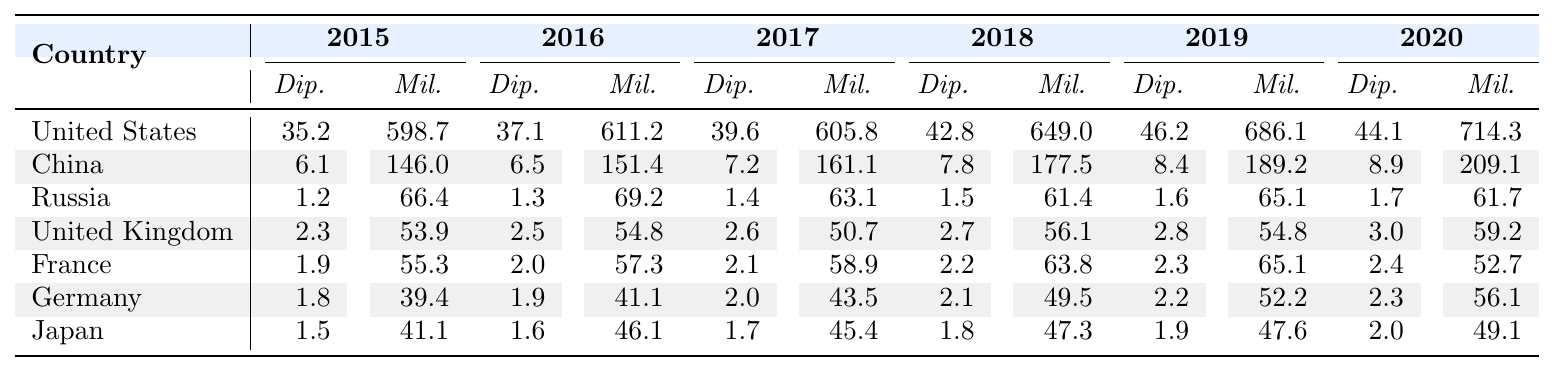What was the military spending of the United States in 2019? According to the table, the military spending for the United States in 2019 is listed as 686.1
Answer: 686.1 Which country had the highest total funding for diplomatic missions in 2020? The table shows that the United States had the highest funding for diplomatic missions in 2020 at 44.1
Answer: United States What is the difference in military spending between Russia and Japan in 2018? In 2018, Russia's military spending was 61.4 and Japan's was 47.3. The difference is 61.4 - 47.3 = 14.1
Answer: 14.1 Did Germany's funding for diplomatic missions exceed 2.0 million in any year? By looking at Germany's diplomatic spending from 2015 to 2020, we see it was always below 2.0 million, reaching a maximum of 2.3 in 2019. Thus, the statement is true.
Answer: Yes Calculate the average military spending for the United Kingdom over the years. The military spending values for the UK are: 53.9, 54.8, 50.7, 56.1, 54.8, and 59.2. Summing them gives 330.5, which when divided by 6 yields an average of 55.08
Answer: 55.1 What was the trend in diplomatic funding for China from 2015 to 2020? By reviewing the values, we can see that China's diplomatic funding increased from 6.1 in 2015 to 8.9 in 2020. This indicates a growing trend over the years.
Answer: Increasing Which country had the lowest military funding in 2017? The table shows that Russia had the lowest military funding in 2017 at 63.1 when compared to other countries listed for that year.
Answer: Russia Was there a decrease in diplomatic funding for France between 2019 and 2020? In 2019, France's diplomatic funding was 2.3 and in 2020 it was 2.4, which indicates an increase, not a decrease.
Answer: No Compare the total diplomatic and military spending for Japan in 2020. Which one was higher? Japan's diplomatic spending in 2020 was 2.0 and military spending was 49.1. Since 49.1 is greater than 2.0, military spending was higher.
Answer: Military spending How much more did the United States spend on military operations compared to diplomatic missions on average from 2015 to 2020? The average military spending for the United States from 2015 - 2020 is (598.7 + 611.2 + 605.8 + 649 + 686.1 + 714.3) / 6 = 628.5, and the average diplomatic spending is (35.2 + 37.1 + 39.6 + 42.8 + 46.2 + 44.1) / 6 = 41.5. The difference is 628.5 - 41.5 = 587
Answer: 587 